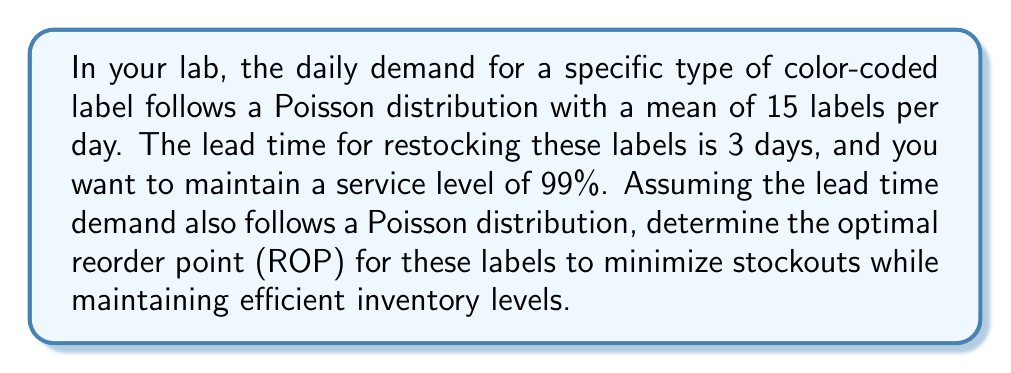Give your solution to this math problem. To solve this problem, we'll follow these steps:

1) First, we need to calculate the mean demand during the lead time. Since the daily demand follows a Poisson distribution with mean 15, and the lead time is 3 days:

   Mean lead time demand = $\lambda = 15 \times 3 = 45$ labels

2) The lead time demand follows a Poisson distribution with mean 45. For a service level of 99%, we need to find the minimum value of $x$ such that:

   $P(X \leq x) \geq 0.99$, where $X$ is the lead time demand

3) For a Poisson distribution, we can use the cumulative distribution function (CDF). We need to find the smallest $x$ where:

   $\sum_{i=0}^x \frac{e^{-\lambda} \lambda^i}{i!} \geq 0.99$

4) Using a statistical table or calculator for the Poisson CDF with $\lambda = 45$, we find:

   $P(X \leq 61) = 0.9893$
   $P(X \leq 62) = 0.9925$

5) Therefore, the smallest value of $x$ that satisfies our condition is 62.

6) The reorder point (ROP) is this value, 62 labels.

This means that when the inventory level drops to 62 labels, a new order should be placed to replenish the stock. This will ensure that 99% of the time, you won't run out of labels during the lead time, while also maintaining efficient inventory levels.
Answer: 62 labels 